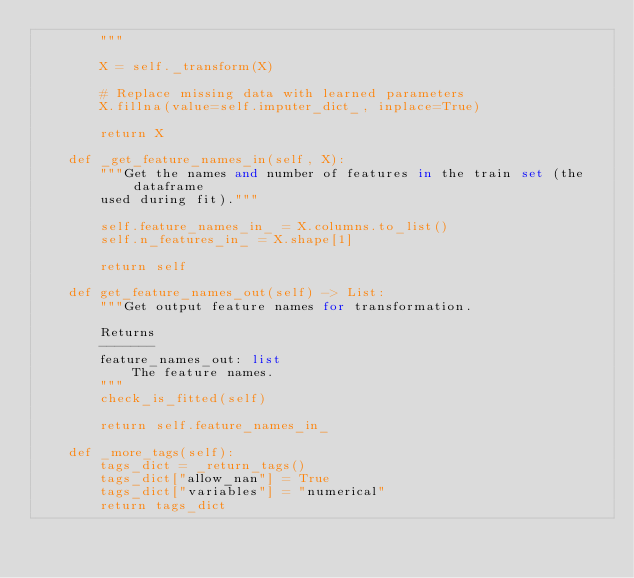<code> <loc_0><loc_0><loc_500><loc_500><_Python_>        """

        X = self._transform(X)

        # Replace missing data with learned parameters
        X.fillna(value=self.imputer_dict_, inplace=True)

        return X

    def _get_feature_names_in(self, X):
        """Get the names and number of features in the train set (the dataframe
        used during fit)."""

        self.feature_names_in_ = X.columns.to_list()
        self.n_features_in_ = X.shape[1]

        return self

    def get_feature_names_out(self) -> List:
        """Get output feature names for transformation.

        Returns
        -------
        feature_names_out: list
            The feature names.
        """
        check_is_fitted(self)

        return self.feature_names_in_

    def _more_tags(self):
        tags_dict = _return_tags()
        tags_dict["allow_nan"] = True
        tags_dict["variables"] = "numerical"
        return tags_dict
</code> 